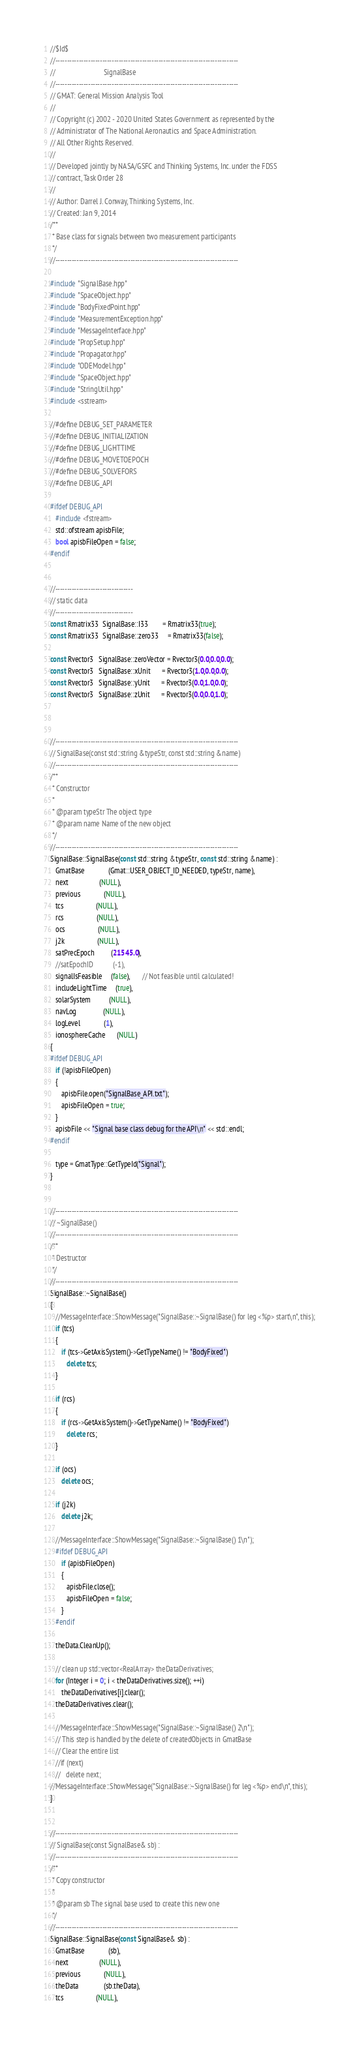<code> <loc_0><loc_0><loc_500><loc_500><_C++_>//$Id$
//------------------------------------------------------------------------------
//                           SignalBase
//------------------------------------------------------------------------------
// GMAT: General Mission Analysis Tool
//
// Copyright (c) 2002 - 2020 United States Government as represented by the
// Administrator of The National Aeronautics and Space Administration.
// All Other Rights Reserved.
//
// Developed jointly by NASA/GSFC and Thinking Systems, Inc. under the FDSS 
// contract, Task Order 28
//
// Author: Darrel J. Conway, Thinking Systems, Inc.
// Created: Jan 9, 2014
/**
 * Base class for signals between two measurement participants
 */
//------------------------------------------------------------------------------

#include "SignalBase.hpp"
#include "SpaceObject.hpp"
#include "BodyFixedPoint.hpp"
#include "MeasurementException.hpp"
#include "MessageInterface.hpp"
#include "PropSetup.hpp"
#include "Propagator.hpp"
#include "ODEModel.hpp"
#include "SpaceObject.hpp"
#include "StringUtil.hpp"
#include <sstream>

//#define DEBUG_SET_PARAMETER
//#define DEBUG_INITIALIZATION
//#define DEBUG_LIGHTTIME
//#define DEBUG_MOVETOEPOCH
//#define DEBUG_SOLVEFORS
//#define DEBUG_API

#ifdef DEBUG_API
   #include <fstream>
   std::ofstream apisbFile;
   bool apisbFileOpen = false;
#endif


//---------------------------------
// static data
//---------------------------------
const Rmatrix33  SignalBase::I33        = Rmatrix33(true);
const Rmatrix33  SignalBase::zero33     = Rmatrix33(false);

const Rvector3   SignalBase::zeroVector = Rvector3(0.0,0.0,0.0);
const Rvector3   SignalBase::xUnit      = Rvector3(1.0,0.0,0.0);
const Rvector3   SignalBase::yUnit      = Rvector3(0.0,1.0,0.0);
const Rvector3   SignalBase::zUnit      = Rvector3(0.0,0.0,1.0);



//------------------------------------------------------------------------------
// SignalBase(const std::string &typeStr, const std::string &name)
//------------------------------------------------------------------------------
/**
 * Constructor
 *
 * @param typeStr The object type
 * @param name Name of the new object
 */
//------------------------------------------------------------------------------
SignalBase::SignalBase(const std::string &typeStr, const std::string &name) :
   GmatBase             (Gmat::USER_OBJECT_ID_NEEDED, typeStr, name),
   next                 (NULL),
   previous             (NULL),
   tcs                  (NULL),
   rcs                  (NULL),
   ocs                  (NULL),
   j2k                  (NULL),
   satPrecEpoch         (21545.0),
   //satEpochID           (-1),
   signalIsFeasible     (false),       // Not feasible until calculated!
   includeLightTime     (true),
   solarSystem          (NULL),
   navLog               (NULL),
   logLevel             (1),
   ionosphereCache      (NULL)
{
#ifdef DEBUG_API
   if (!apisbFileOpen)
   {
      apisbFile.open("SignalBase_API.txt");
      apisbFileOpen = true;
   }
   apisbFile << "Signal base class debug for the API\n" << std::endl;
#endif

   type = GmatType::GetTypeId("Signal");
}


//------------------------------------------------------------------------------
// ~SignalBase()
//------------------------------------------------------------------------------
/**
 * Destructor
 */
//------------------------------------------------------------------------------
SignalBase::~SignalBase()
{
   //MessageInterface::ShowMessage("SignalBase::~SignalBase() for leg <%p> start\n", this);
   if (tcs)
   {
      if (tcs->GetAxisSystem()->GetTypeName() != "BodyFixed")
         delete tcs;
   }
   
   if (rcs)
   {
      if (rcs->GetAxisSystem()->GetTypeName() != "BodyFixed")
         delete rcs;
   }
   
   if (ocs)
      delete ocs;
   
   if (j2k)
      delete j2k;
   
   //MessageInterface::ShowMessage("SignalBase::~SignalBase() 1\n");
   #ifdef DEBUG_API
      if (apisbFileOpen)
      {
         apisbFile.close();
         apisbFileOpen = false;
      }
   #endif

   theData.CleanUp();
   
   // clean up std::vector<RealArray> theDataDerivatives;
   for (Integer i = 0; i < theDataDerivatives.size(); ++i)
      theDataDerivatives[i].clear();
   theDataDerivatives.clear();
   
   //MessageInterface::ShowMessage("SignalBase::~SignalBase() 2\n");
   // This step is handled by the delete of createdObjects in GmatBase
   // Clear the entire list
   //if (next)
   //   delete next;
//MessageInterface::ShowMessage("SignalBase::~SignalBase() for leg <%p> end\n", this);
}


//------------------------------------------------------------------------------
// SignalBase(const SignalBase& sb) :
//------------------------------------------------------------------------------
/**
 * Copy constructor
 *
 * @param sb The signal base used to create this new one
 */
//------------------------------------------------------------------------------
SignalBase::SignalBase(const SignalBase& sb) :
   GmatBase             (sb),
   next                 (NULL),
   previous             (NULL),
   theData              (sb.theData),
   tcs                  (NULL),</code> 